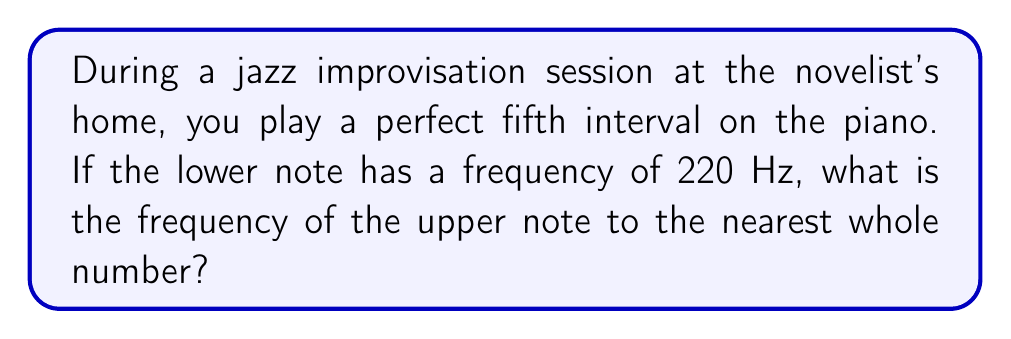Show me your answer to this math problem. To solve this problem, we need to understand the frequency ratios of musical intervals, particularly the perfect fifth in jazz harmony.

1. The perfect fifth interval has a frequency ratio of 3:2.

2. Let's denote the frequency of the lower note as $f_1$ and the upper note as $f_2$.

3. We can express their relationship using the ratio:

   $$\frac{f_2}{f_1} = \frac{3}{2}$$

4. We know that $f_1 = 220$ Hz. Let's substitute this into our equation:

   $$\frac{f_2}{220} = \frac{3}{2}$$

5. To solve for $f_2$, we multiply both sides by 220:

   $$f_2 = 220 \cdot \frac{3}{2}$$

6. Now we can calculate:

   $$f_2 = 220 \cdot \frac{3}{2} = \frac{220 \cdot 3}{2} = \frac{660}{2} = 330$$

7. The question asks for the nearest whole number, but 330 is already a whole number.

Therefore, the frequency of the upper note in the perfect fifth interval is 330 Hz.
Answer: 330 Hz 